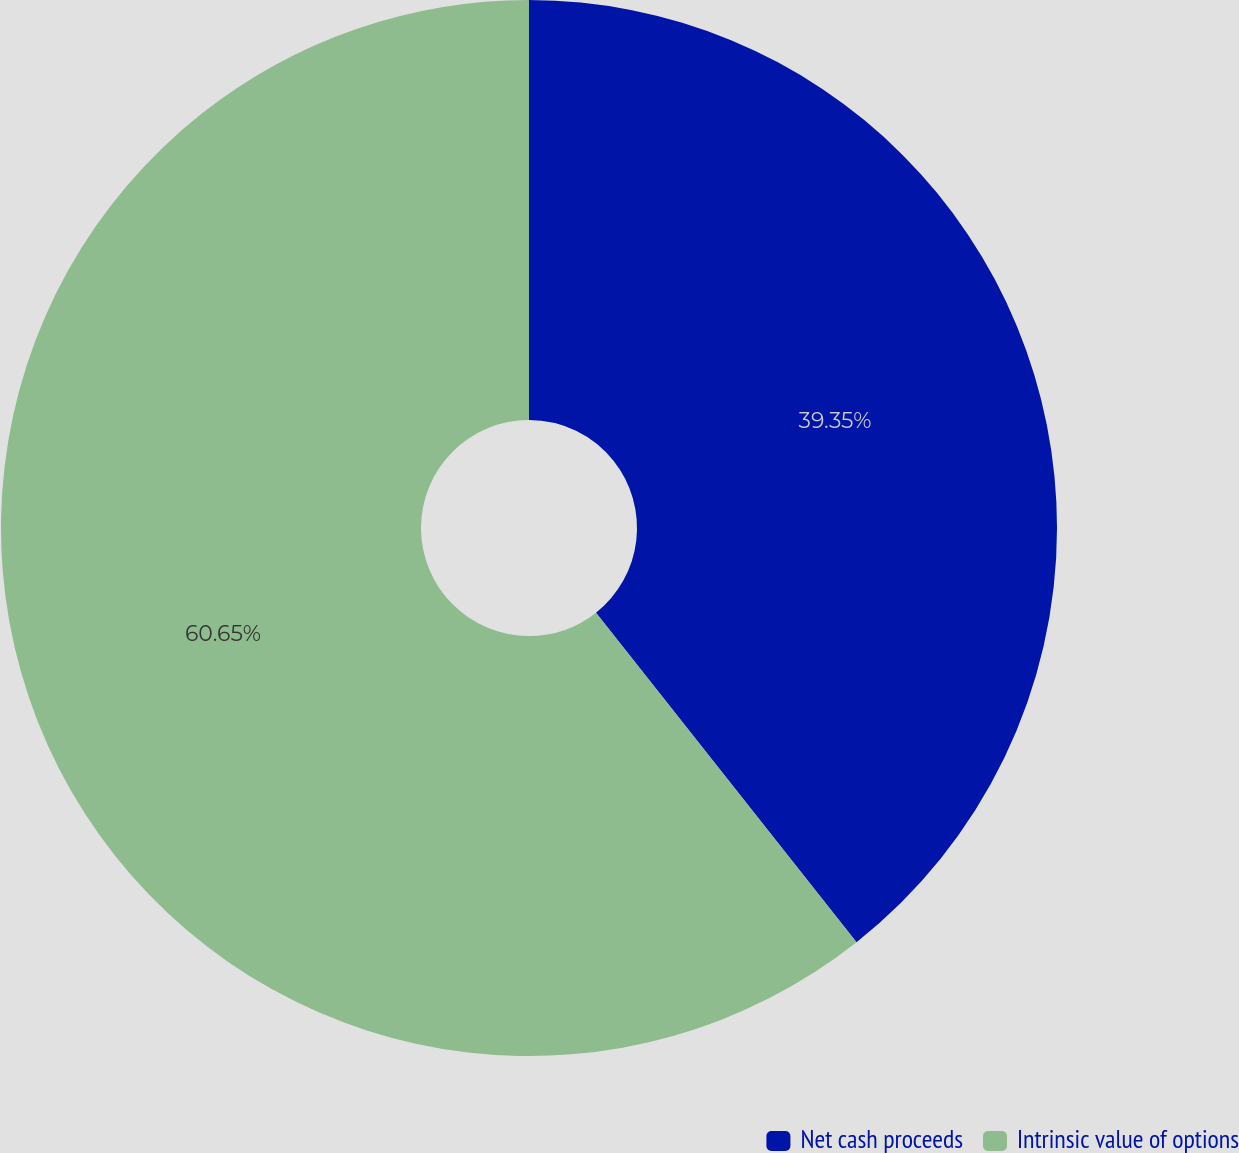Convert chart to OTSL. <chart><loc_0><loc_0><loc_500><loc_500><pie_chart><fcel>Net cash proceeds<fcel>Intrinsic value of options<nl><fcel>39.35%<fcel>60.65%<nl></chart> 